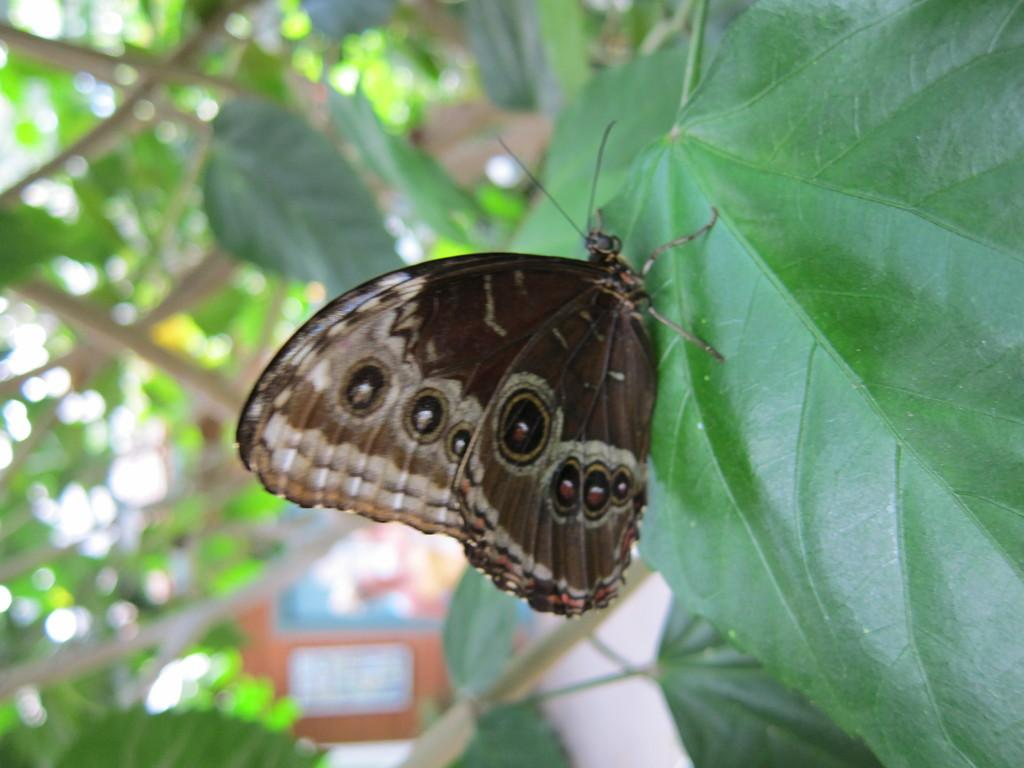What is the main subject of the image? There is a butterfly in the image. Where is the butterfly located? The butterfly is on a leaf of a tree. What color is the butterfly? The butterfly is brown in color. Can you describe the background of the image? The background of the image is blurred. What type of kite is being used to cover the butterfly in the image? There is no kite or any attempt to cover the butterfly in the image; the butterfly is on a leaf of a tree. What type of playground equipment can be seen in the image? There is no playground equipment present in the image; it features a brown butterfly on a leaf of a tree. 